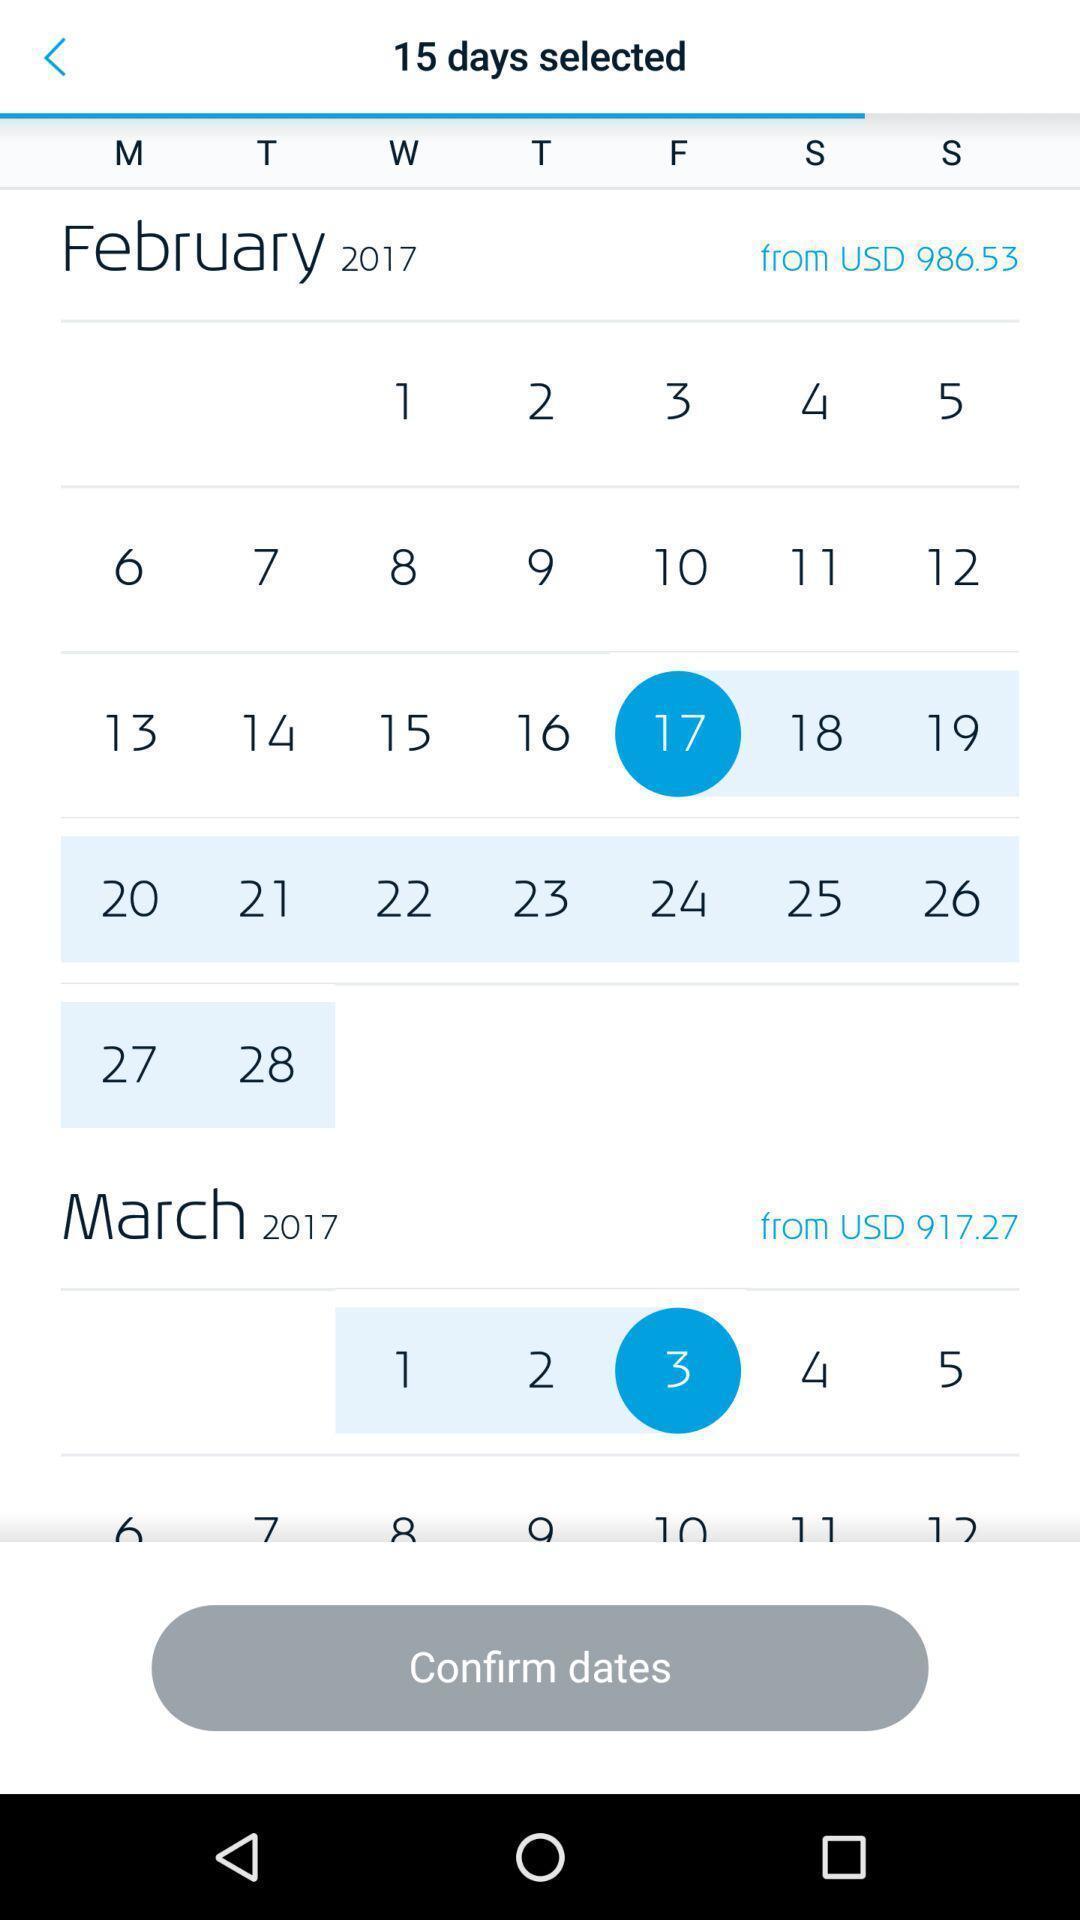Describe the key features of this screenshot. Page showing calendar and marked dates. 